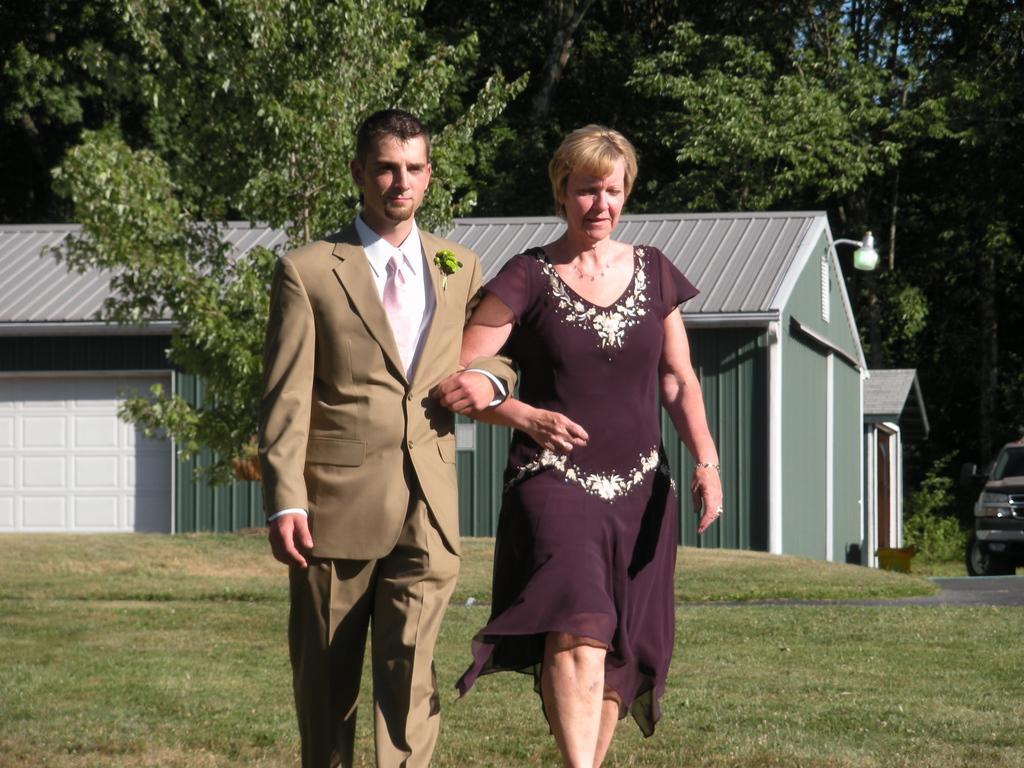Please provide a concise description of this image. In this image, we can see a human and man are holding hands with each other and walking. Background we can see few houses, vehicle, grass, road and trees. 